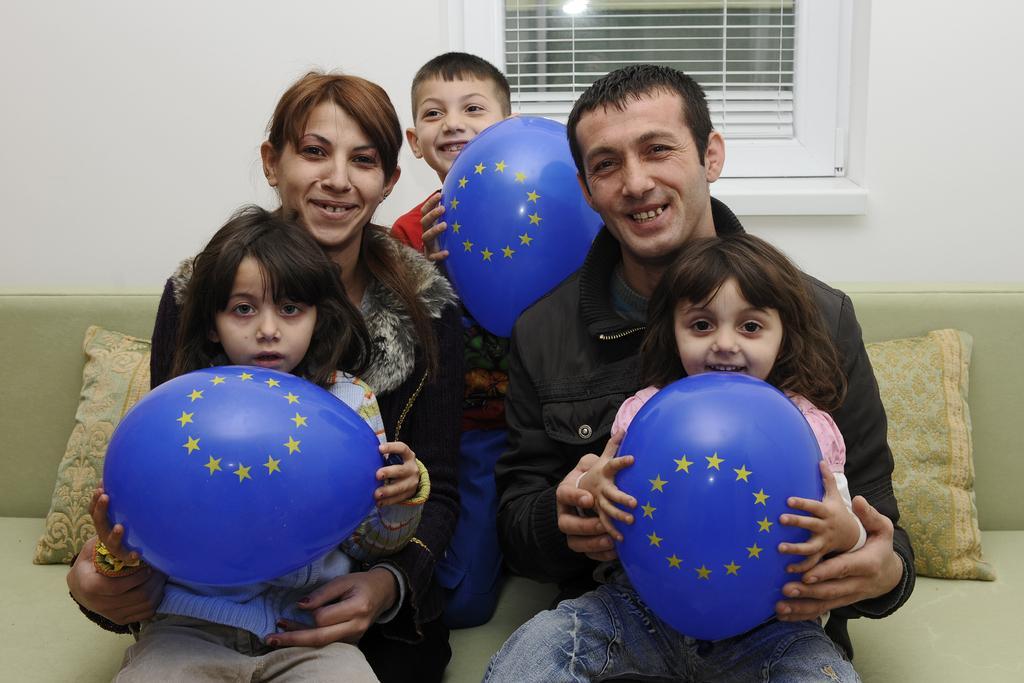Please provide a concise description of this image. In this image, we can see two persons wearing clothes and sitting on the sofa. There are three kids holding balloons with their hands. There is a window at the top of the image. 